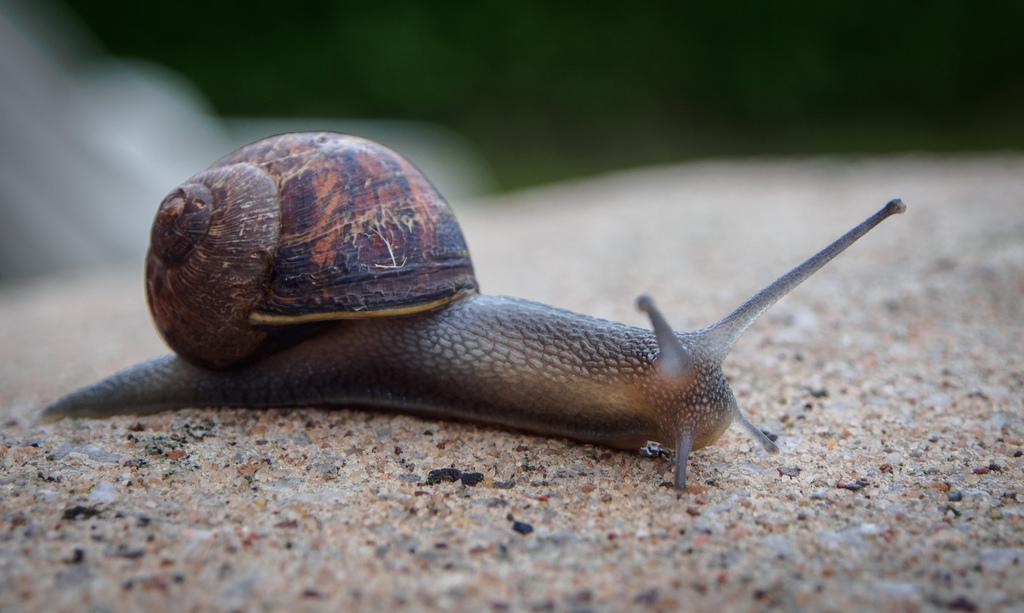What is the main subject in the center of the image? There is a snail in the center of the image. How many rats are running in the rain near the cars in the image? There are no rats, rain, or cars present in the image; it only features a snail. 